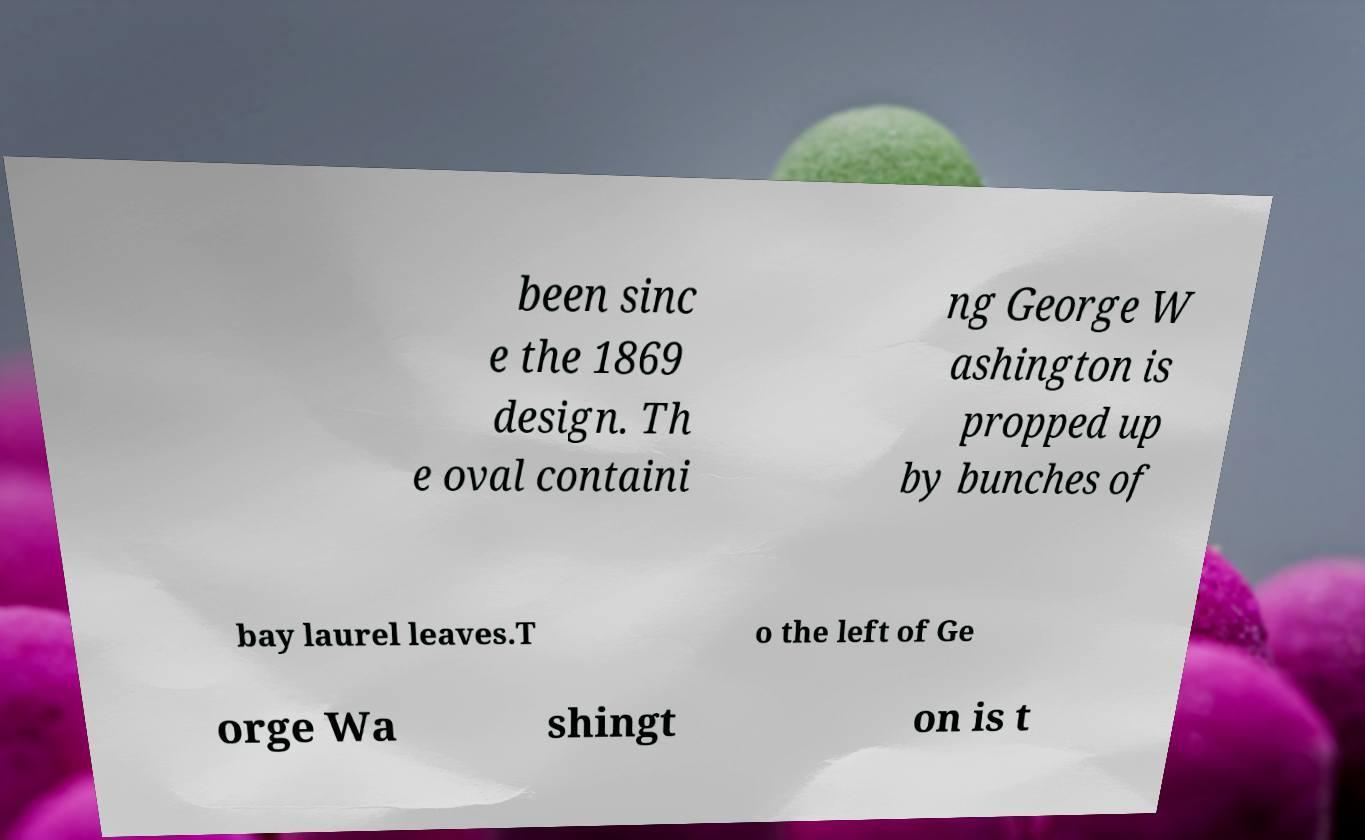Please identify and transcribe the text found in this image. been sinc e the 1869 design. Th e oval containi ng George W ashington is propped up by bunches of bay laurel leaves.T o the left of Ge orge Wa shingt on is t 